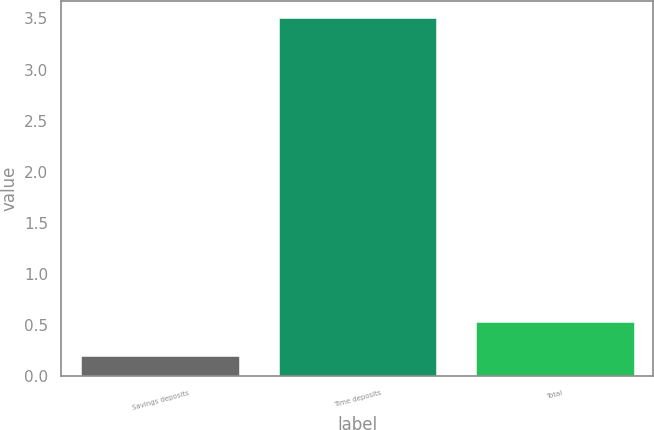Convert chart. <chart><loc_0><loc_0><loc_500><loc_500><bar_chart><fcel>Savings deposits<fcel>Time deposits<fcel>Total<nl><fcel>0.2<fcel>3.5<fcel>0.53<nl></chart> 